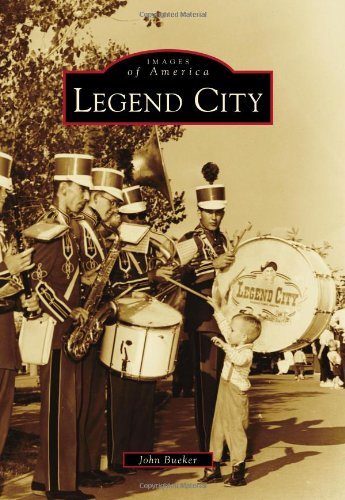What is the title of this book? The title of the book is 'Legend City (Images of America).' It's part of the 'Images of America' series by Arcadia Publishing, which documents the history of places across the United States through rich photographic content. 